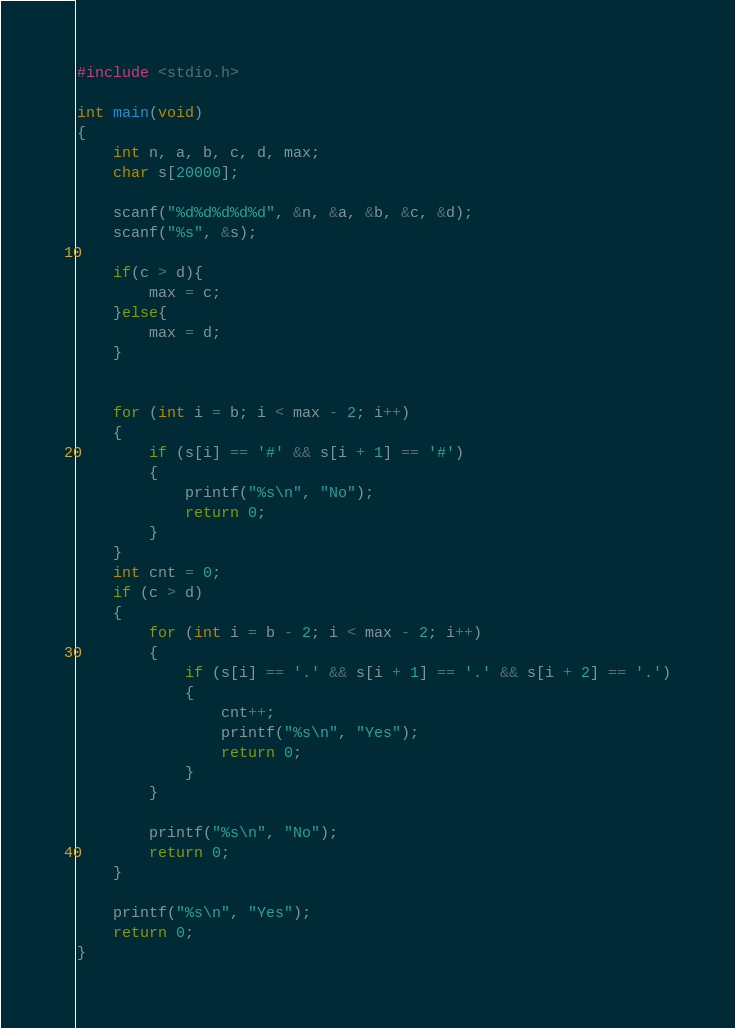Convert code to text. <code><loc_0><loc_0><loc_500><loc_500><_C_>#include <stdio.h>

int main(void)
{
    int n, a, b, c, d, max;
    char s[20000];

    scanf("%d%d%d%d%d", &n, &a, &b, &c, &d);
    scanf("%s", &s);

    if(c > d){
        max = c;
    }else{
        max = d;
    }


    for (int i = b; i < max - 2; i++)
    {
        if (s[i] == '#' && s[i + 1] == '#')
        {
            printf("%s\n", "No");
            return 0;
        }
    }
    int cnt = 0;
    if (c > d)
    {
        for (int i = b - 2; i < max - 2; i++)
        {
            if (s[i] == '.' && s[i + 1] == '.' && s[i + 2] == '.')
            {
                cnt++;
                printf("%s\n", "Yes");
                return 0;
            }
        }

        printf("%s\n", "No");
        return 0;
    }

    printf("%s\n", "Yes");
    return 0;
}
</code> 